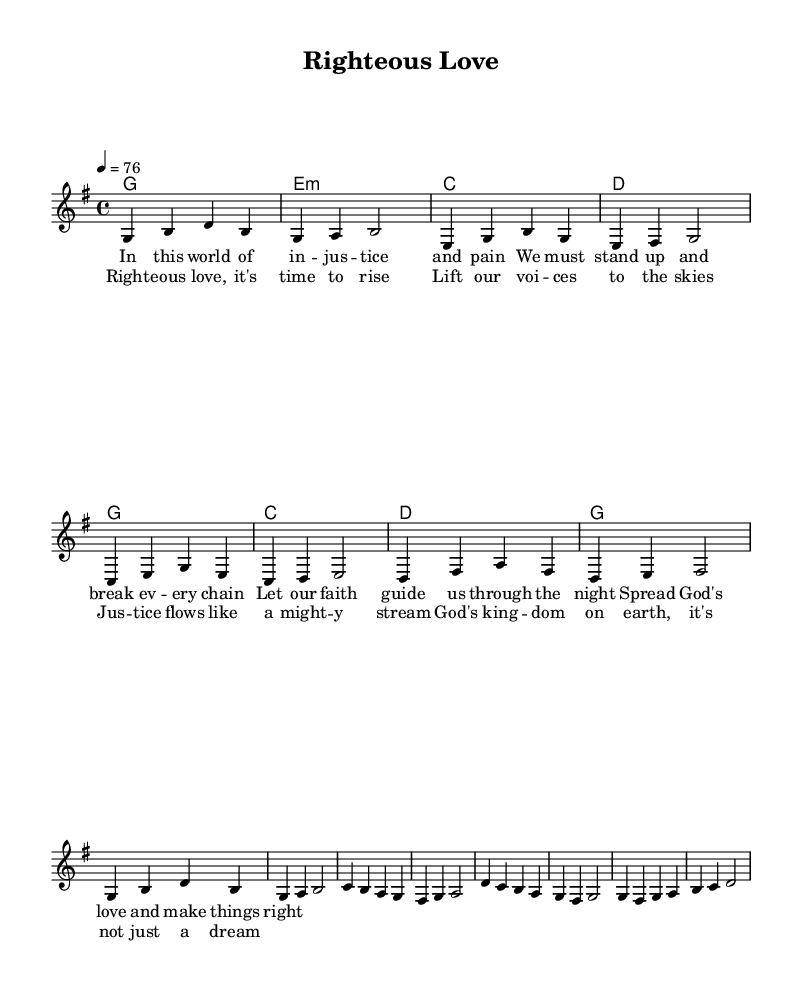What is the key signature of this music? The key signature indicated in the music is G major, which has one sharp (F#).
Answer: G major What is the time signature of the piece? The time signature is shown as 4/4, which means there are four beats in each measure and the quarter note gets one beat.
Answer: 4/4 What is the tempo marking for the song? The tempo marking states that the tempo is 76 beats per minute, giving a moderate pace for the song.
Answer: 76 How many verses does the song have? The lyrics provided only outline one complete verse, marked before the chorus section.
Answer: 1 Which musical form does the song primarily follow? The song follows a verse-chorus structure, which is typical in many reggae songs, alternating between these parts.
Answer: Verse-chorus What message does the lyrics convey from a religious perspective? The lyrics emphasize themes of justice, faith, and love, aligning with social justice by encouraging the audience to act against injustice through faith and love.
Answer: Social justice What is unique about this reggae song compared to typical reggae themes? This song specifically integrates themes of social justice and faith, moving beyond typical reggae themes of love or social celebrations, focusing on a righteous call to action.
Answer: Social justice and faith 